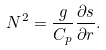<formula> <loc_0><loc_0><loc_500><loc_500>N ^ { 2 } = \frac { g } { C _ { p } } \frac { \partial s } { \partial r } .</formula> 